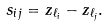<formula> <loc_0><loc_0><loc_500><loc_500>s _ { i j } = z _ { \ell _ { i } } - z _ { \ell _ { j } } .</formula> 